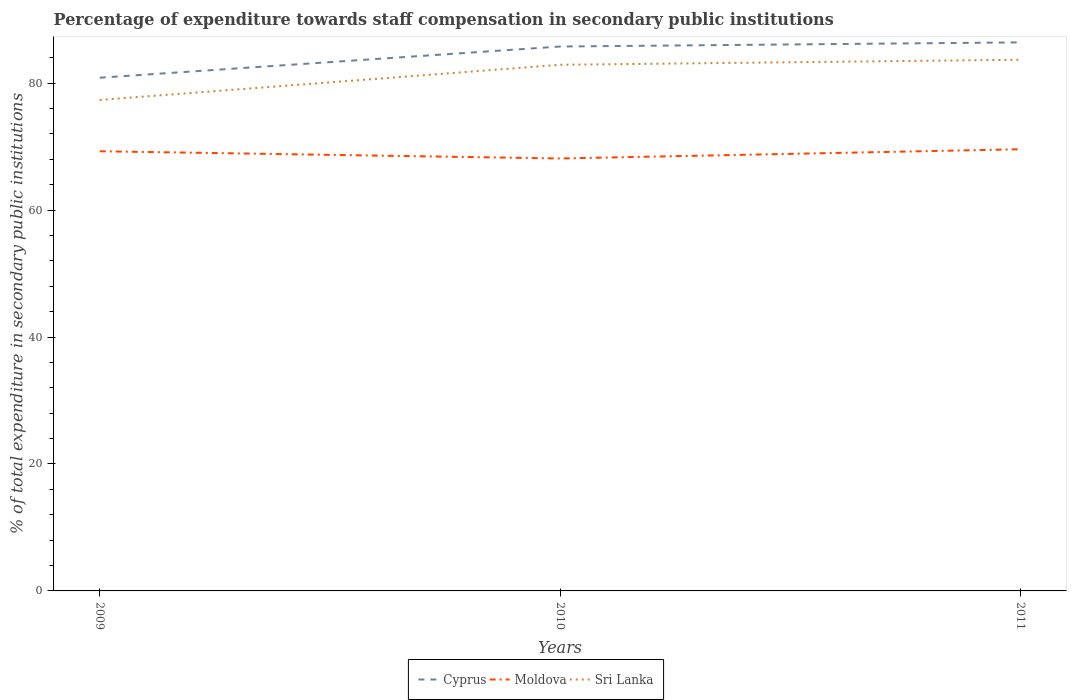How many different coloured lines are there?
Offer a very short reply. 3. Across all years, what is the maximum percentage of expenditure towards staff compensation in Cyprus?
Give a very brief answer. 80.85. What is the total percentage of expenditure towards staff compensation in Moldova in the graph?
Keep it short and to the point. -1.45. What is the difference between the highest and the second highest percentage of expenditure towards staff compensation in Moldova?
Provide a short and direct response. 1.45. How many years are there in the graph?
Your answer should be very brief. 3. Does the graph contain any zero values?
Your answer should be very brief. No. Where does the legend appear in the graph?
Your answer should be compact. Bottom center. How are the legend labels stacked?
Keep it short and to the point. Horizontal. What is the title of the graph?
Offer a terse response. Percentage of expenditure towards staff compensation in secondary public institutions. What is the label or title of the X-axis?
Ensure brevity in your answer.  Years. What is the label or title of the Y-axis?
Your response must be concise. % of total expenditure in secondary public institutions. What is the % of total expenditure in secondary public institutions of Cyprus in 2009?
Make the answer very short. 80.85. What is the % of total expenditure in secondary public institutions of Moldova in 2009?
Make the answer very short. 69.27. What is the % of total expenditure in secondary public institutions in Sri Lanka in 2009?
Give a very brief answer. 77.35. What is the % of total expenditure in secondary public institutions in Cyprus in 2010?
Provide a short and direct response. 85.76. What is the % of total expenditure in secondary public institutions in Moldova in 2010?
Ensure brevity in your answer.  68.13. What is the % of total expenditure in secondary public institutions of Sri Lanka in 2010?
Your answer should be compact. 82.88. What is the % of total expenditure in secondary public institutions of Cyprus in 2011?
Provide a short and direct response. 86.42. What is the % of total expenditure in secondary public institutions of Moldova in 2011?
Keep it short and to the point. 69.58. What is the % of total expenditure in secondary public institutions in Sri Lanka in 2011?
Provide a succinct answer. 83.68. Across all years, what is the maximum % of total expenditure in secondary public institutions in Cyprus?
Provide a short and direct response. 86.42. Across all years, what is the maximum % of total expenditure in secondary public institutions of Moldova?
Provide a short and direct response. 69.58. Across all years, what is the maximum % of total expenditure in secondary public institutions of Sri Lanka?
Make the answer very short. 83.68. Across all years, what is the minimum % of total expenditure in secondary public institutions in Cyprus?
Give a very brief answer. 80.85. Across all years, what is the minimum % of total expenditure in secondary public institutions of Moldova?
Keep it short and to the point. 68.13. Across all years, what is the minimum % of total expenditure in secondary public institutions in Sri Lanka?
Offer a terse response. 77.35. What is the total % of total expenditure in secondary public institutions in Cyprus in the graph?
Keep it short and to the point. 253.03. What is the total % of total expenditure in secondary public institutions in Moldova in the graph?
Provide a succinct answer. 206.97. What is the total % of total expenditure in secondary public institutions in Sri Lanka in the graph?
Keep it short and to the point. 243.92. What is the difference between the % of total expenditure in secondary public institutions of Cyprus in 2009 and that in 2010?
Ensure brevity in your answer.  -4.91. What is the difference between the % of total expenditure in secondary public institutions in Moldova in 2009 and that in 2010?
Make the answer very short. 1.14. What is the difference between the % of total expenditure in secondary public institutions in Sri Lanka in 2009 and that in 2010?
Your answer should be compact. -5.53. What is the difference between the % of total expenditure in secondary public institutions in Cyprus in 2009 and that in 2011?
Keep it short and to the point. -5.57. What is the difference between the % of total expenditure in secondary public institutions of Moldova in 2009 and that in 2011?
Your answer should be very brief. -0.31. What is the difference between the % of total expenditure in secondary public institutions in Sri Lanka in 2009 and that in 2011?
Offer a very short reply. -6.33. What is the difference between the % of total expenditure in secondary public institutions in Cyprus in 2010 and that in 2011?
Ensure brevity in your answer.  -0.65. What is the difference between the % of total expenditure in secondary public institutions of Moldova in 2010 and that in 2011?
Give a very brief answer. -1.45. What is the difference between the % of total expenditure in secondary public institutions in Sri Lanka in 2010 and that in 2011?
Offer a very short reply. -0.8. What is the difference between the % of total expenditure in secondary public institutions of Cyprus in 2009 and the % of total expenditure in secondary public institutions of Moldova in 2010?
Make the answer very short. 12.72. What is the difference between the % of total expenditure in secondary public institutions in Cyprus in 2009 and the % of total expenditure in secondary public institutions in Sri Lanka in 2010?
Provide a succinct answer. -2.03. What is the difference between the % of total expenditure in secondary public institutions of Moldova in 2009 and the % of total expenditure in secondary public institutions of Sri Lanka in 2010?
Give a very brief answer. -13.62. What is the difference between the % of total expenditure in secondary public institutions in Cyprus in 2009 and the % of total expenditure in secondary public institutions in Moldova in 2011?
Keep it short and to the point. 11.27. What is the difference between the % of total expenditure in secondary public institutions of Cyprus in 2009 and the % of total expenditure in secondary public institutions of Sri Lanka in 2011?
Ensure brevity in your answer.  -2.83. What is the difference between the % of total expenditure in secondary public institutions in Moldova in 2009 and the % of total expenditure in secondary public institutions in Sri Lanka in 2011?
Ensure brevity in your answer.  -14.42. What is the difference between the % of total expenditure in secondary public institutions of Cyprus in 2010 and the % of total expenditure in secondary public institutions of Moldova in 2011?
Your answer should be very brief. 16.18. What is the difference between the % of total expenditure in secondary public institutions in Cyprus in 2010 and the % of total expenditure in secondary public institutions in Sri Lanka in 2011?
Your answer should be very brief. 2.08. What is the difference between the % of total expenditure in secondary public institutions in Moldova in 2010 and the % of total expenditure in secondary public institutions in Sri Lanka in 2011?
Provide a short and direct response. -15.56. What is the average % of total expenditure in secondary public institutions of Cyprus per year?
Ensure brevity in your answer.  84.34. What is the average % of total expenditure in secondary public institutions in Moldova per year?
Offer a very short reply. 68.99. What is the average % of total expenditure in secondary public institutions in Sri Lanka per year?
Your answer should be very brief. 81.31. In the year 2009, what is the difference between the % of total expenditure in secondary public institutions in Cyprus and % of total expenditure in secondary public institutions in Moldova?
Offer a terse response. 11.59. In the year 2009, what is the difference between the % of total expenditure in secondary public institutions in Cyprus and % of total expenditure in secondary public institutions in Sri Lanka?
Keep it short and to the point. 3.5. In the year 2009, what is the difference between the % of total expenditure in secondary public institutions of Moldova and % of total expenditure in secondary public institutions of Sri Lanka?
Your answer should be compact. -8.09. In the year 2010, what is the difference between the % of total expenditure in secondary public institutions of Cyprus and % of total expenditure in secondary public institutions of Moldova?
Give a very brief answer. 17.64. In the year 2010, what is the difference between the % of total expenditure in secondary public institutions of Cyprus and % of total expenditure in secondary public institutions of Sri Lanka?
Give a very brief answer. 2.88. In the year 2010, what is the difference between the % of total expenditure in secondary public institutions of Moldova and % of total expenditure in secondary public institutions of Sri Lanka?
Your answer should be very brief. -14.76. In the year 2011, what is the difference between the % of total expenditure in secondary public institutions of Cyprus and % of total expenditure in secondary public institutions of Moldova?
Provide a succinct answer. 16.84. In the year 2011, what is the difference between the % of total expenditure in secondary public institutions in Cyprus and % of total expenditure in secondary public institutions in Sri Lanka?
Give a very brief answer. 2.73. In the year 2011, what is the difference between the % of total expenditure in secondary public institutions in Moldova and % of total expenditure in secondary public institutions in Sri Lanka?
Ensure brevity in your answer.  -14.1. What is the ratio of the % of total expenditure in secondary public institutions of Cyprus in 2009 to that in 2010?
Provide a succinct answer. 0.94. What is the ratio of the % of total expenditure in secondary public institutions of Moldova in 2009 to that in 2010?
Make the answer very short. 1.02. What is the ratio of the % of total expenditure in secondary public institutions of Sri Lanka in 2009 to that in 2010?
Offer a very short reply. 0.93. What is the ratio of the % of total expenditure in secondary public institutions in Cyprus in 2009 to that in 2011?
Offer a terse response. 0.94. What is the ratio of the % of total expenditure in secondary public institutions in Sri Lanka in 2009 to that in 2011?
Your answer should be very brief. 0.92. What is the ratio of the % of total expenditure in secondary public institutions in Moldova in 2010 to that in 2011?
Provide a succinct answer. 0.98. What is the difference between the highest and the second highest % of total expenditure in secondary public institutions in Cyprus?
Your answer should be very brief. 0.65. What is the difference between the highest and the second highest % of total expenditure in secondary public institutions in Moldova?
Make the answer very short. 0.31. What is the difference between the highest and the second highest % of total expenditure in secondary public institutions of Sri Lanka?
Your response must be concise. 0.8. What is the difference between the highest and the lowest % of total expenditure in secondary public institutions in Cyprus?
Offer a terse response. 5.57. What is the difference between the highest and the lowest % of total expenditure in secondary public institutions in Moldova?
Offer a very short reply. 1.45. What is the difference between the highest and the lowest % of total expenditure in secondary public institutions of Sri Lanka?
Offer a terse response. 6.33. 